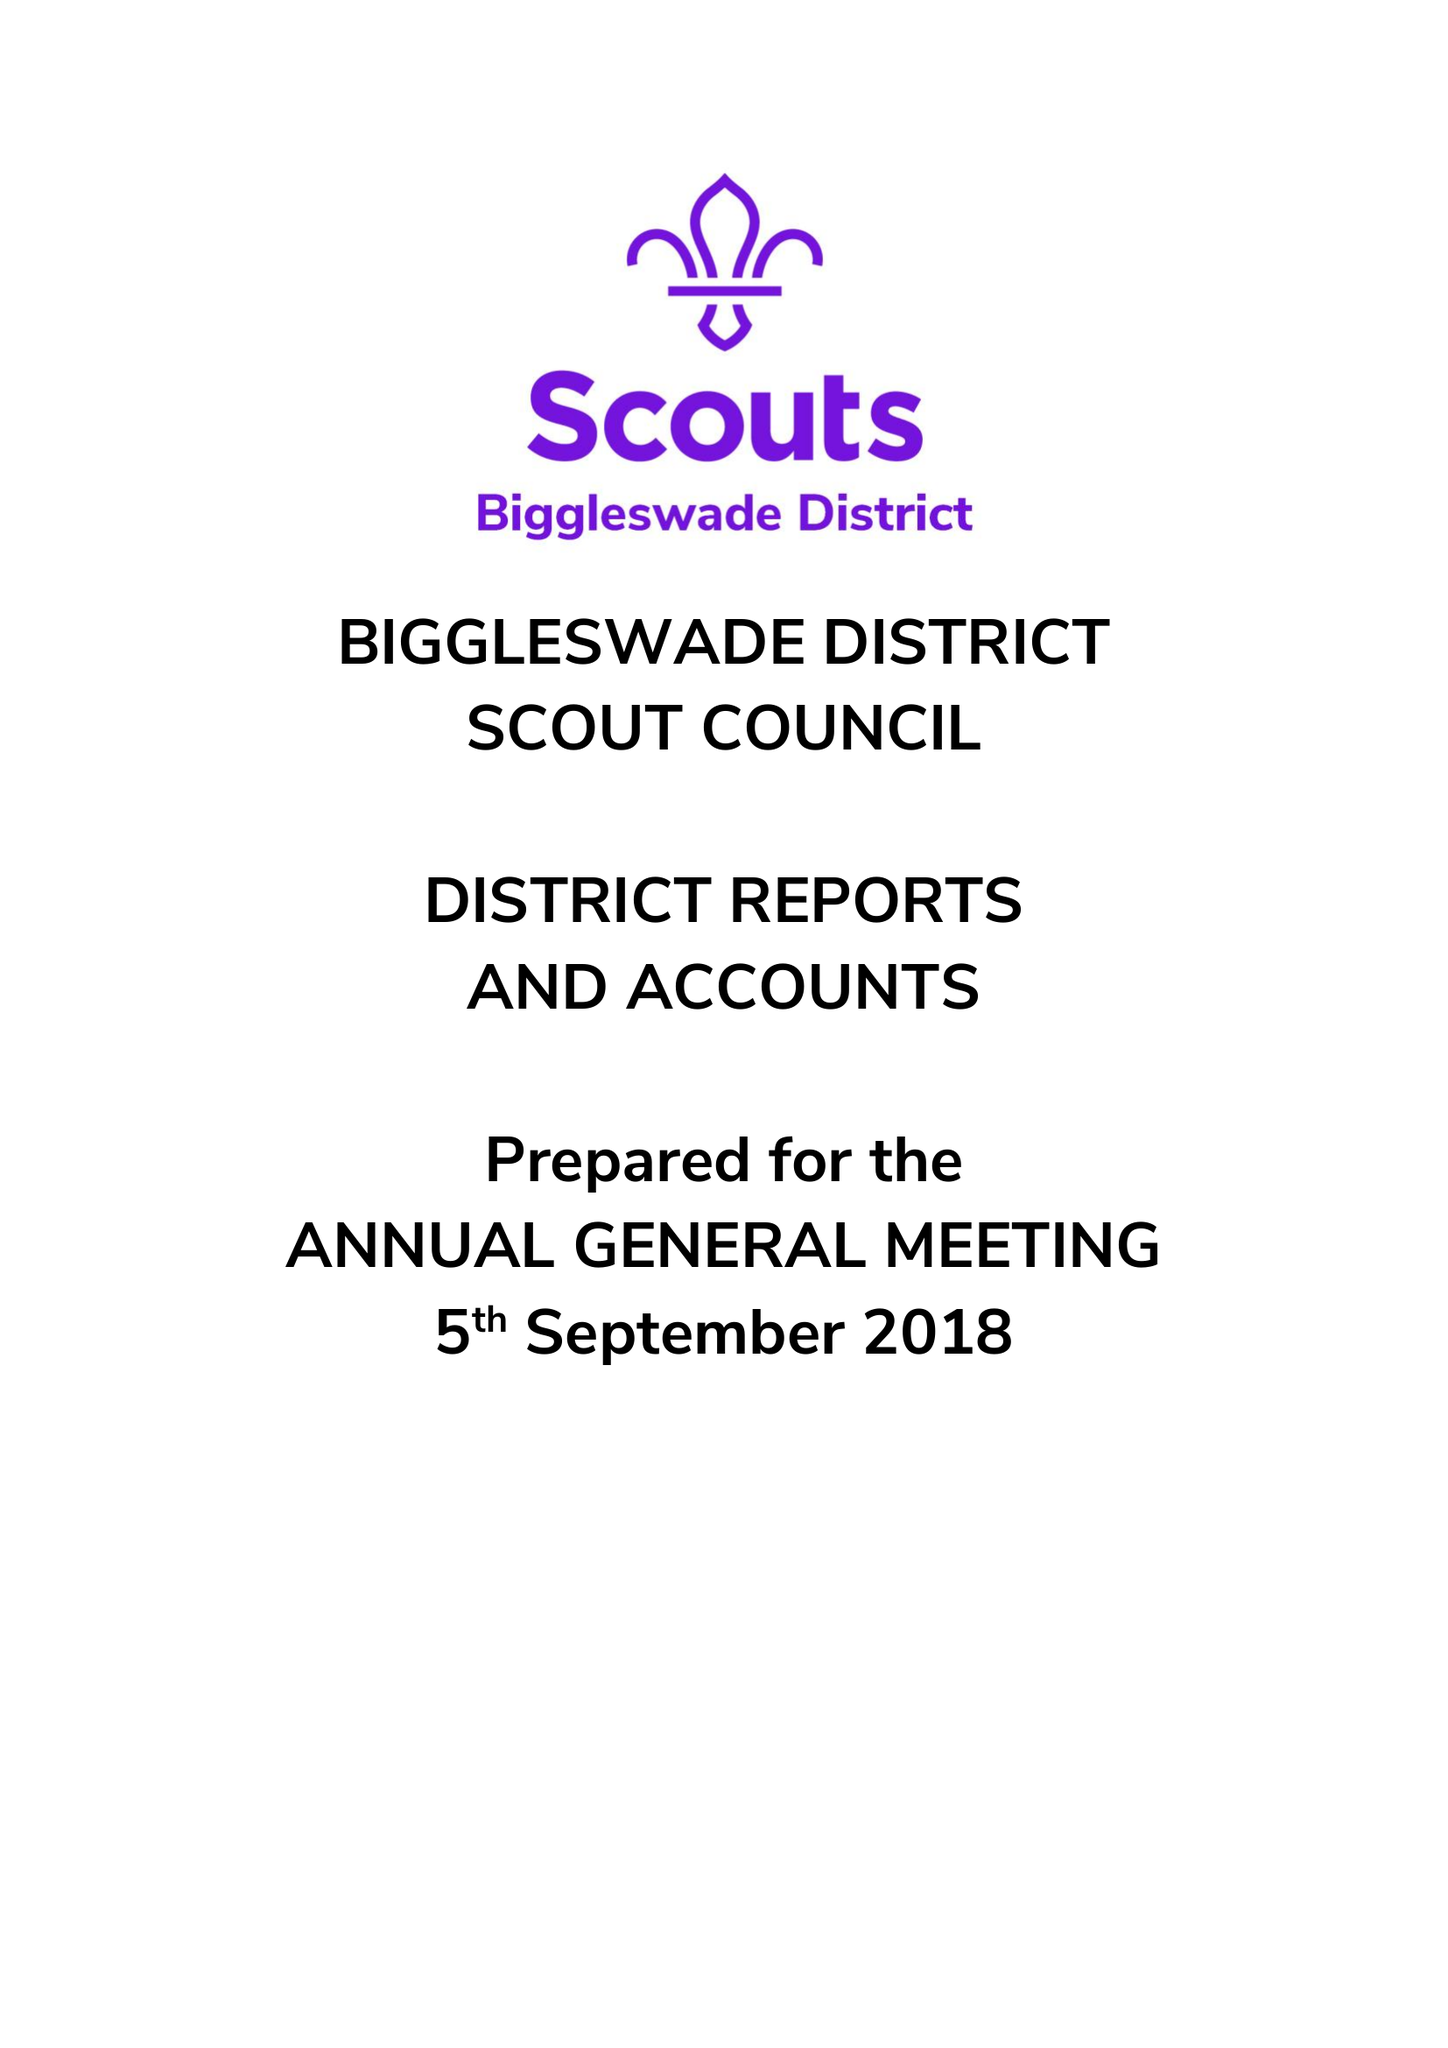What is the value for the address__postcode?
Answer the question using a single word or phrase. SG18 0RQ 